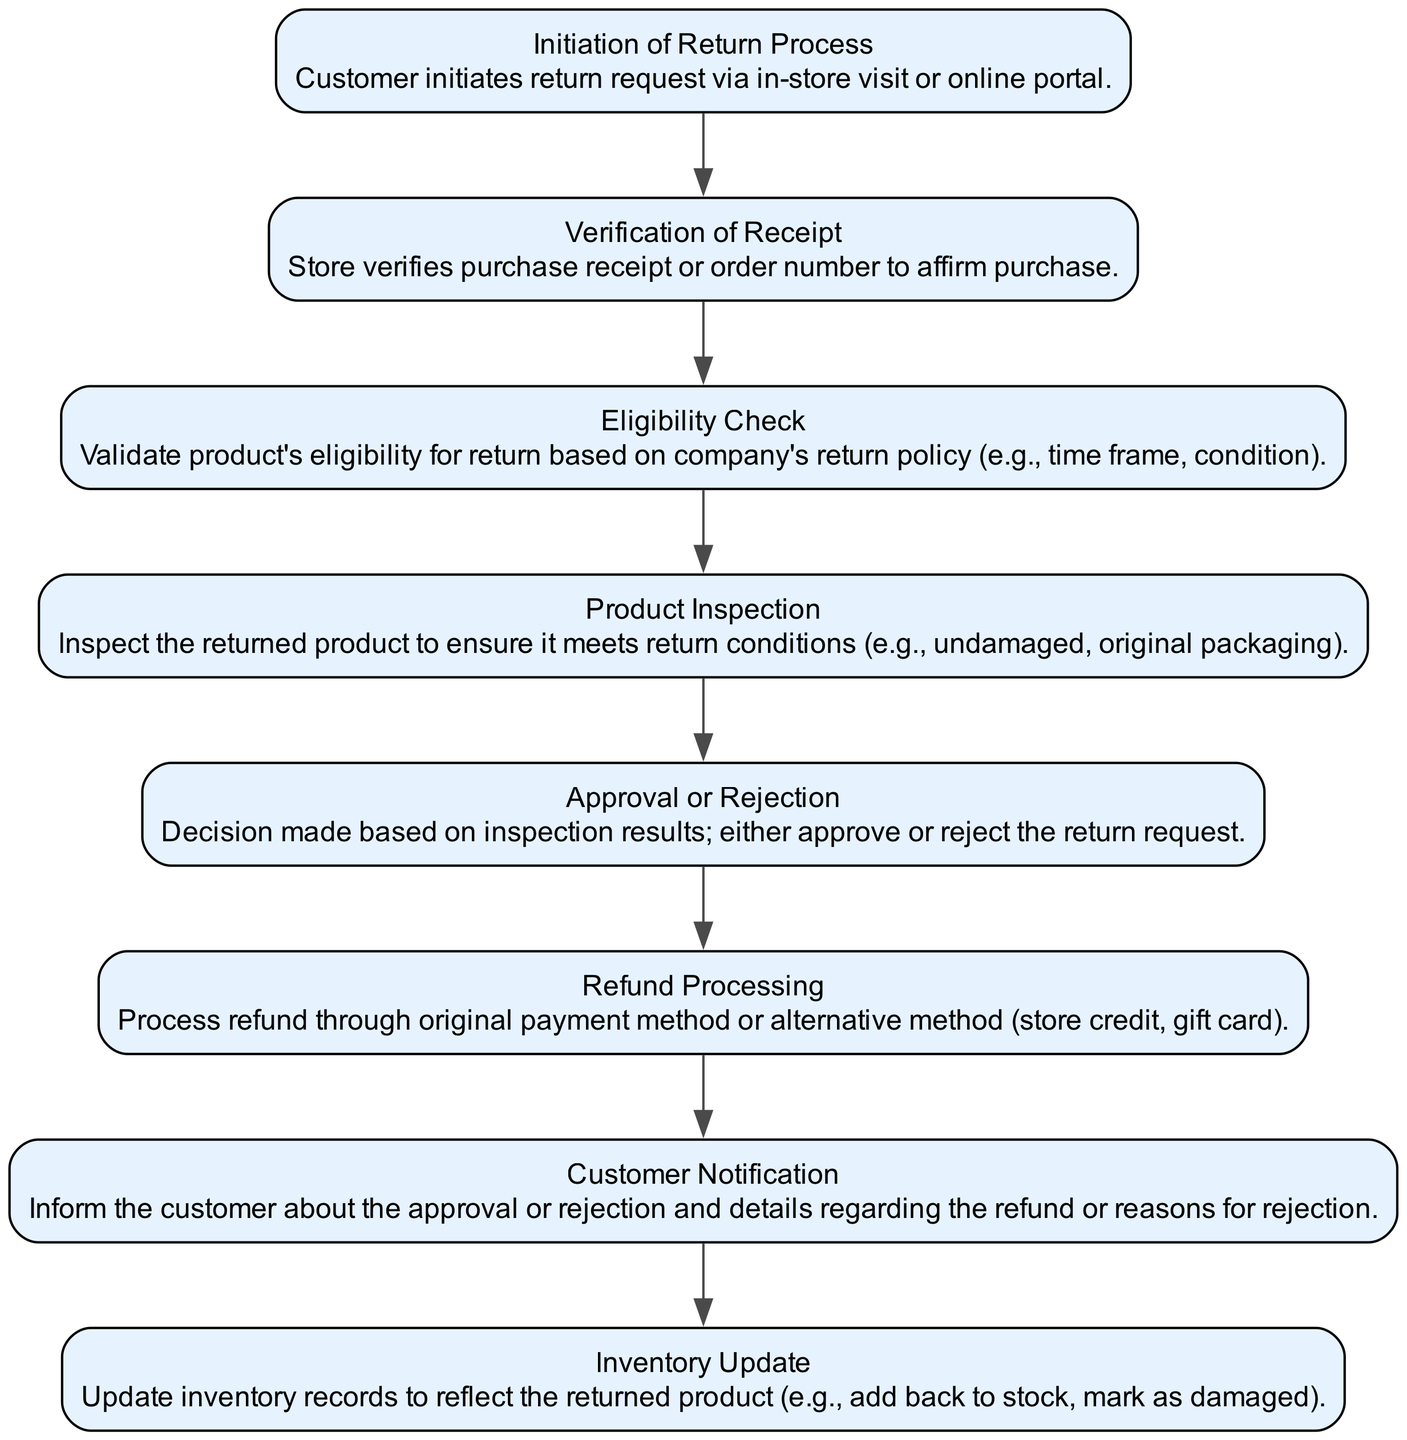What is the first step in the return process? The first step is labeled "Initiation of Return Process," where the customer initiates a return request either in-store or online.
Answer: Initiation of Return Process How many nodes are in the flow chart? The flow chart contains eight nodes, each representing a step in the return and refund process.
Answer: Eight What happens after the "Verification of Receipt"? After verifying the receipt, the next step is the "Eligibility Check," where the product's return eligibility is validated against the company's return policy.
Answer: Eligibility Check What is the final step in the return process? The final step is "Inventory Update," which updates inventory records reflecting the returned product's status.
Answer: Inventory Update What is the action taken if the product is approved for return? If approved, the action taken is "Refund Processing," where the refund is processed through the original payment method or an alternative method.
Answer: Refund Processing Which step involves informing the customer? The step that involves informing the customer is "Customer Notification," where details regarding the approval or rejection and refund information are provided.
Answer: Customer Notification What occurs before "Product Inspection"? Before the "Product Inspection," the step labeled "Eligibility Check" must be completed to ensure the product can be returned.
Answer: Eligibility Check Which two steps occur before "Refund Processing"? Before "Refund Processing," the two preceding steps are "Approval or Rejection" and "Customer Notification."
Answer: Approval or Rejection, Customer Notification 